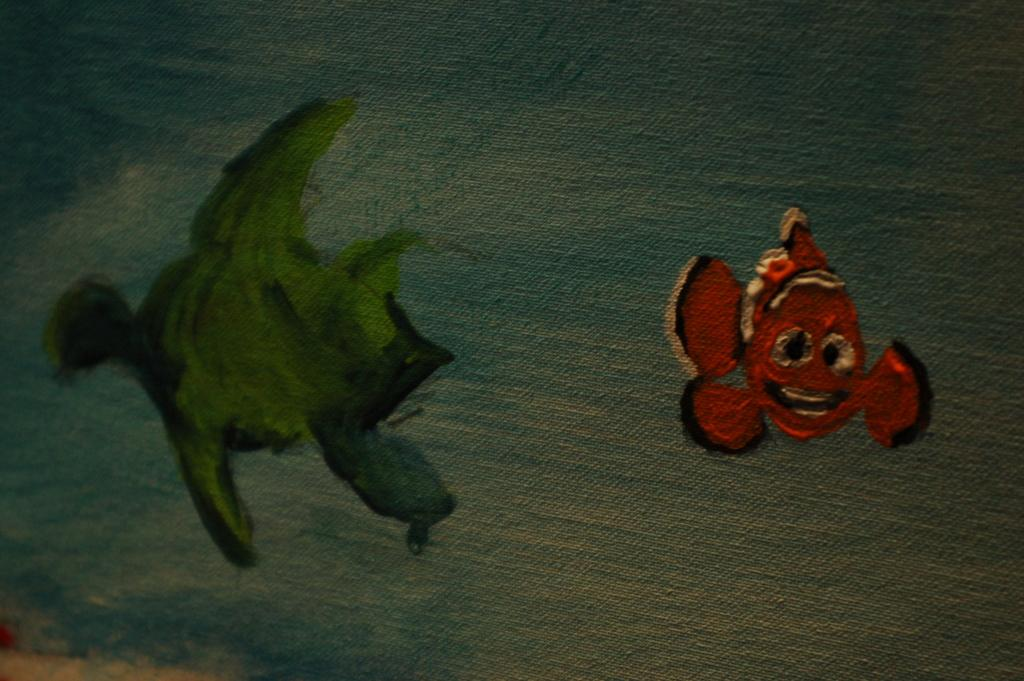What is the main subject of the painting? The main subject of the painting is two fishes. What colors are used to depict the fishes? The fishes are in orange, black, and green colors. How would you describe the background of the painting? The background of the painting is in blue and white colors. What type of apparel is the secretary wearing in the painting? There is no secretary or apparel present in the painting; it depicts two fishes in a blue and white background. 